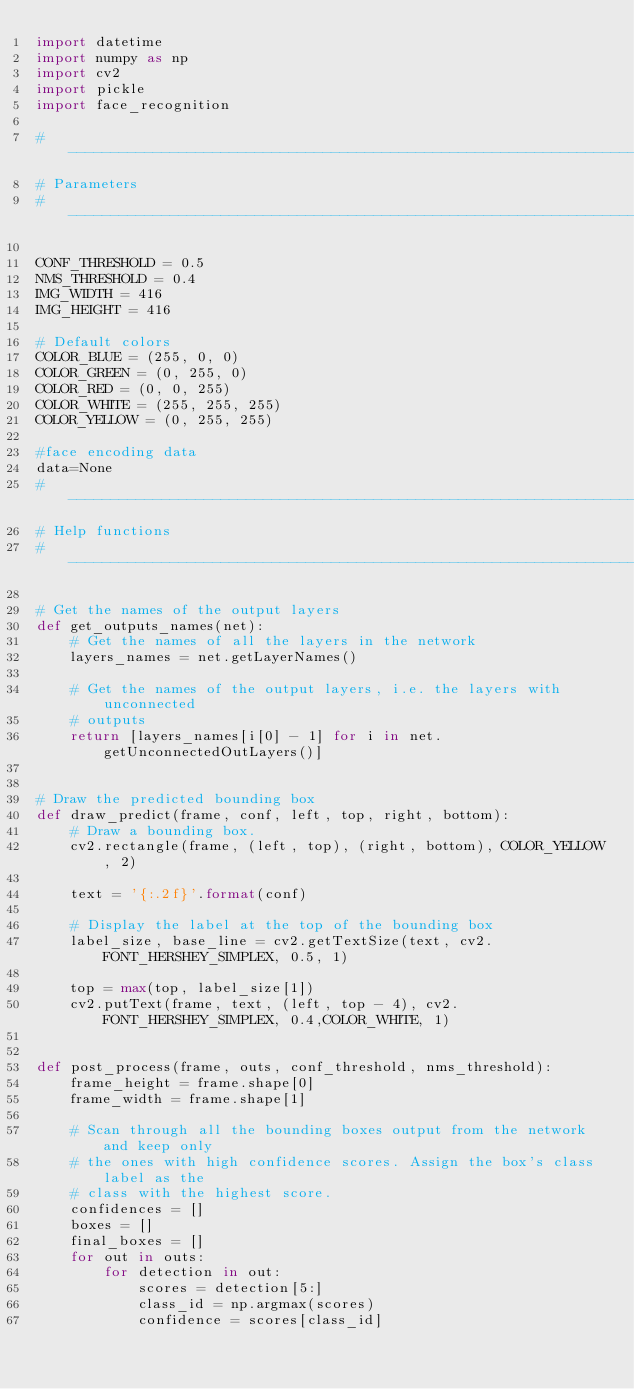<code> <loc_0><loc_0><loc_500><loc_500><_Python_>import datetime
import numpy as np
import cv2
import pickle
import face_recognition

# -------------------------------------------------------------------
# Parameters
# -------------------------------------------------------------------

CONF_THRESHOLD = 0.5
NMS_THRESHOLD = 0.4
IMG_WIDTH = 416
IMG_HEIGHT = 416

# Default colors
COLOR_BLUE = (255, 0, 0)
COLOR_GREEN = (0, 255, 0)
COLOR_RED = (0, 0, 255)
COLOR_WHITE = (255, 255, 255)
COLOR_YELLOW = (0, 255, 255)

#face encoding data
data=None
# -------------------------------------------------------------------
# Help functions
# -------------------------------------------------------------------

# Get the names of the output layers
def get_outputs_names(net):
    # Get the names of all the layers in the network
    layers_names = net.getLayerNames()

    # Get the names of the output layers, i.e. the layers with unconnected
    # outputs
    return [layers_names[i[0] - 1] for i in net.getUnconnectedOutLayers()]


# Draw the predicted bounding box
def draw_predict(frame, conf, left, top, right, bottom):
    # Draw a bounding box.
    cv2.rectangle(frame, (left, top), (right, bottom), COLOR_YELLOW, 2)

    text = '{:.2f}'.format(conf)

    # Display the label at the top of the bounding box
    label_size, base_line = cv2.getTextSize(text, cv2.FONT_HERSHEY_SIMPLEX, 0.5, 1)

    top = max(top, label_size[1])
    cv2.putText(frame, text, (left, top - 4), cv2.FONT_HERSHEY_SIMPLEX, 0.4,COLOR_WHITE, 1)


def post_process(frame, outs, conf_threshold, nms_threshold):
    frame_height = frame.shape[0]
    frame_width = frame.shape[1]

    # Scan through all the bounding boxes output from the network and keep only
    # the ones with high confidence scores. Assign the box's class label as the
    # class with the highest score.
    confidences = []
    boxes = []
    final_boxes = []
    for out in outs:
        for detection in out:
            scores = detection[5:]
            class_id = np.argmax(scores)
            confidence = scores[class_id]</code> 